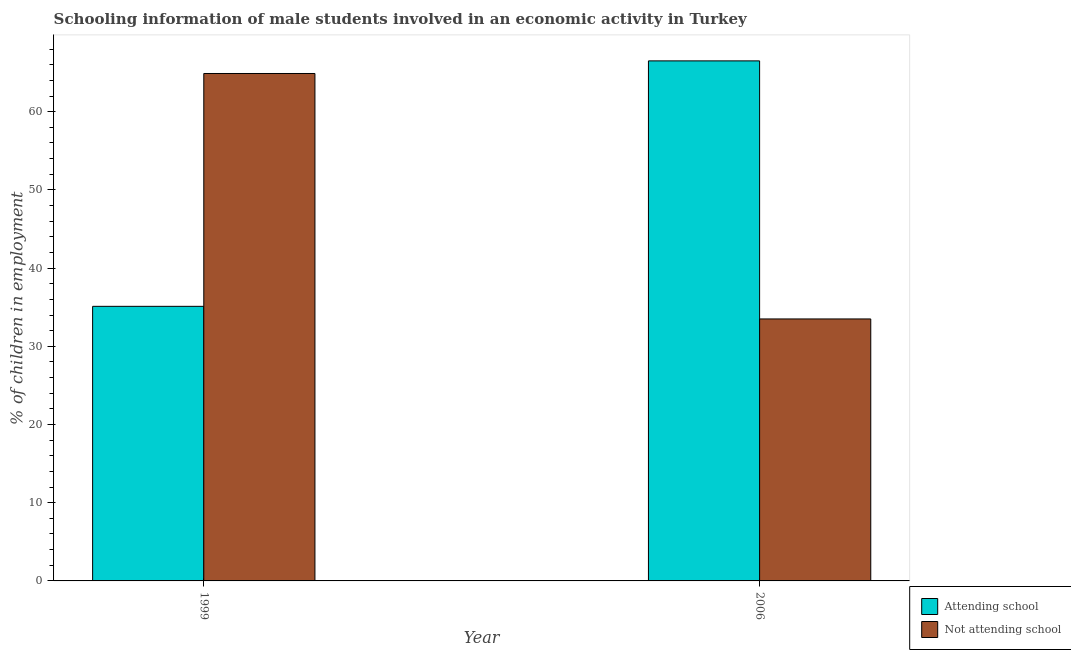How many different coloured bars are there?
Your answer should be very brief. 2. How many groups of bars are there?
Provide a short and direct response. 2. Are the number of bars on each tick of the X-axis equal?
Offer a terse response. Yes. How many bars are there on the 1st tick from the right?
Your answer should be compact. 2. What is the label of the 2nd group of bars from the left?
Offer a very short reply. 2006. In how many cases, is the number of bars for a given year not equal to the number of legend labels?
Provide a succinct answer. 0. What is the percentage of employed males who are not attending school in 1999?
Keep it short and to the point. 64.89. Across all years, what is the maximum percentage of employed males who are not attending school?
Your answer should be very brief. 64.89. Across all years, what is the minimum percentage of employed males who are attending school?
Keep it short and to the point. 35.11. In which year was the percentage of employed males who are attending school minimum?
Provide a succinct answer. 1999. What is the total percentage of employed males who are attending school in the graph?
Your response must be concise. 101.61. What is the difference between the percentage of employed males who are not attending school in 1999 and that in 2006?
Your response must be concise. 31.39. What is the difference between the percentage of employed males who are attending school in 2006 and the percentage of employed males who are not attending school in 1999?
Give a very brief answer. 31.39. What is the average percentage of employed males who are not attending school per year?
Offer a very short reply. 49.19. In how many years, is the percentage of employed males who are not attending school greater than 58 %?
Provide a short and direct response. 1. What is the ratio of the percentage of employed males who are not attending school in 1999 to that in 2006?
Offer a terse response. 1.94. What does the 1st bar from the left in 2006 represents?
Ensure brevity in your answer.  Attending school. What does the 2nd bar from the right in 2006 represents?
Ensure brevity in your answer.  Attending school. Are all the bars in the graph horizontal?
Make the answer very short. No. Where does the legend appear in the graph?
Make the answer very short. Bottom right. How many legend labels are there?
Your response must be concise. 2. How are the legend labels stacked?
Offer a very short reply. Vertical. What is the title of the graph?
Your response must be concise. Schooling information of male students involved in an economic activity in Turkey. Does "Money lenders" appear as one of the legend labels in the graph?
Your answer should be compact. No. What is the label or title of the Y-axis?
Provide a short and direct response. % of children in employment. What is the % of children in employment of Attending school in 1999?
Provide a succinct answer. 35.11. What is the % of children in employment of Not attending school in 1999?
Provide a succinct answer. 64.89. What is the % of children in employment of Attending school in 2006?
Offer a very short reply. 66.5. What is the % of children in employment of Not attending school in 2006?
Ensure brevity in your answer.  33.5. Across all years, what is the maximum % of children in employment in Attending school?
Offer a very short reply. 66.5. Across all years, what is the maximum % of children in employment of Not attending school?
Give a very brief answer. 64.89. Across all years, what is the minimum % of children in employment in Attending school?
Your answer should be very brief. 35.11. Across all years, what is the minimum % of children in employment of Not attending school?
Your answer should be compact. 33.5. What is the total % of children in employment in Attending school in the graph?
Offer a very short reply. 101.61. What is the total % of children in employment of Not attending school in the graph?
Your answer should be compact. 98.39. What is the difference between the % of children in employment in Attending school in 1999 and that in 2006?
Make the answer very short. -31.39. What is the difference between the % of children in employment in Not attending school in 1999 and that in 2006?
Your answer should be very brief. 31.39. What is the difference between the % of children in employment of Attending school in 1999 and the % of children in employment of Not attending school in 2006?
Keep it short and to the point. 1.61. What is the average % of children in employment of Attending school per year?
Make the answer very short. 50.81. What is the average % of children in employment of Not attending school per year?
Give a very brief answer. 49.19. In the year 1999, what is the difference between the % of children in employment of Attending school and % of children in employment of Not attending school?
Offer a terse response. -29.77. In the year 2006, what is the difference between the % of children in employment in Attending school and % of children in employment in Not attending school?
Provide a short and direct response. 33. What is the ratio of the % of children in employment of Attending school in 1999 to that in 2006?
Keep it short and to the point. 0.53. What is the ratio of the % of children in employment in Not attending school in 1999 to that in 2006?
Provide a succinct answer. 1.94. What is the difference between the highest and the second highest % of children in employment in Attending school?
Give a very brief answer. 31.39. What is the difference between the highest and the second highest % of children in employment of Not attending school?
Keep it short and to the point. 31.39. What is the difference between the highest and the lowest % of children in employment of Attending school?
Make the answer very short. 31.39. What is the difference between the highest and the lowest % of children in employment of Not attending school?
Offer a very short reply. 31.39. 